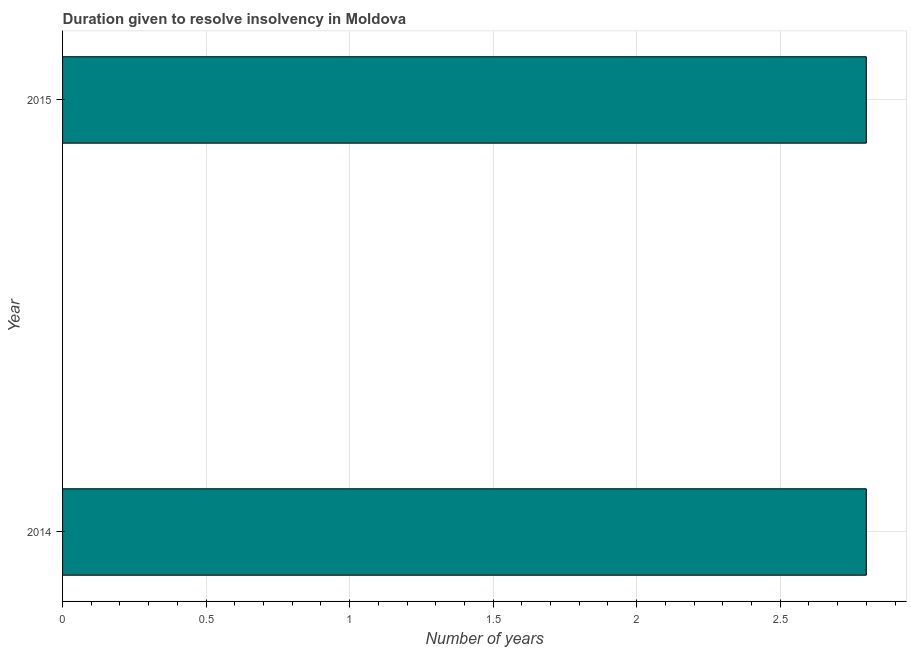Does the graph contain any zero values?
Give a very brief answer. No. Does the graph contain grids?
Your response must be concise. Yes. What is the title of the graph?
Provide a succinct answer. Duration given to resolve insolvency in Moldova. What is the label or title of the X-axis?
Your answer should be very brief. Number of years. What is the label or title of the Y-axis?
Provide a succinct answer. Year. What is the number of years to resolve insolvency in 2015?
Provide a short and direct response. 2.8. Across all years, what is the maximum number of years to resolve insolvency?
Offer a very short reply. 2.8. In which year was the number of years to resolve insolvency maximum?
Keep it short and to the point. 2014. What is the sum of the number of years to resolve insolvency?
Ensure brevity in your answer.  5.6. What is the difference between the number of years to resolve insolvency in 2014 and 2015?
Make the answer very short. 0. What is the average number of years to resolve insolvency per year?
Make the answer very short. 2.8. In how many years, is the number of years to resolve insolvency greater than 1.4 ?
Your answer should be compact. 2. Do a majority of the years between 2015 and 2014 (inclusive) have number of years to resolve insolvency greater than 2.1 ?
Your answer should be compact. No. What is the ratio of the number of years to resolve insolvency in 2014 to that in 2015?
Your response must be concise. 1. In how many years, is the number of years to resolve insolvency greater than the average number of years to resolve insolvency taken over all years?
Offer a very short reply. 0. Are all the bars in the graph horizontal?
Ensure brevity in your answer.  Yes. Are the values on the major ticks of X-axis written in scientific E-notation?
Offer a very short reply. No. What is the Number of years in 2015?
Make the answer very short. 2.8. What is the difference between the Number of years in 2014 and 2015?
Offer a terse response. 0. 